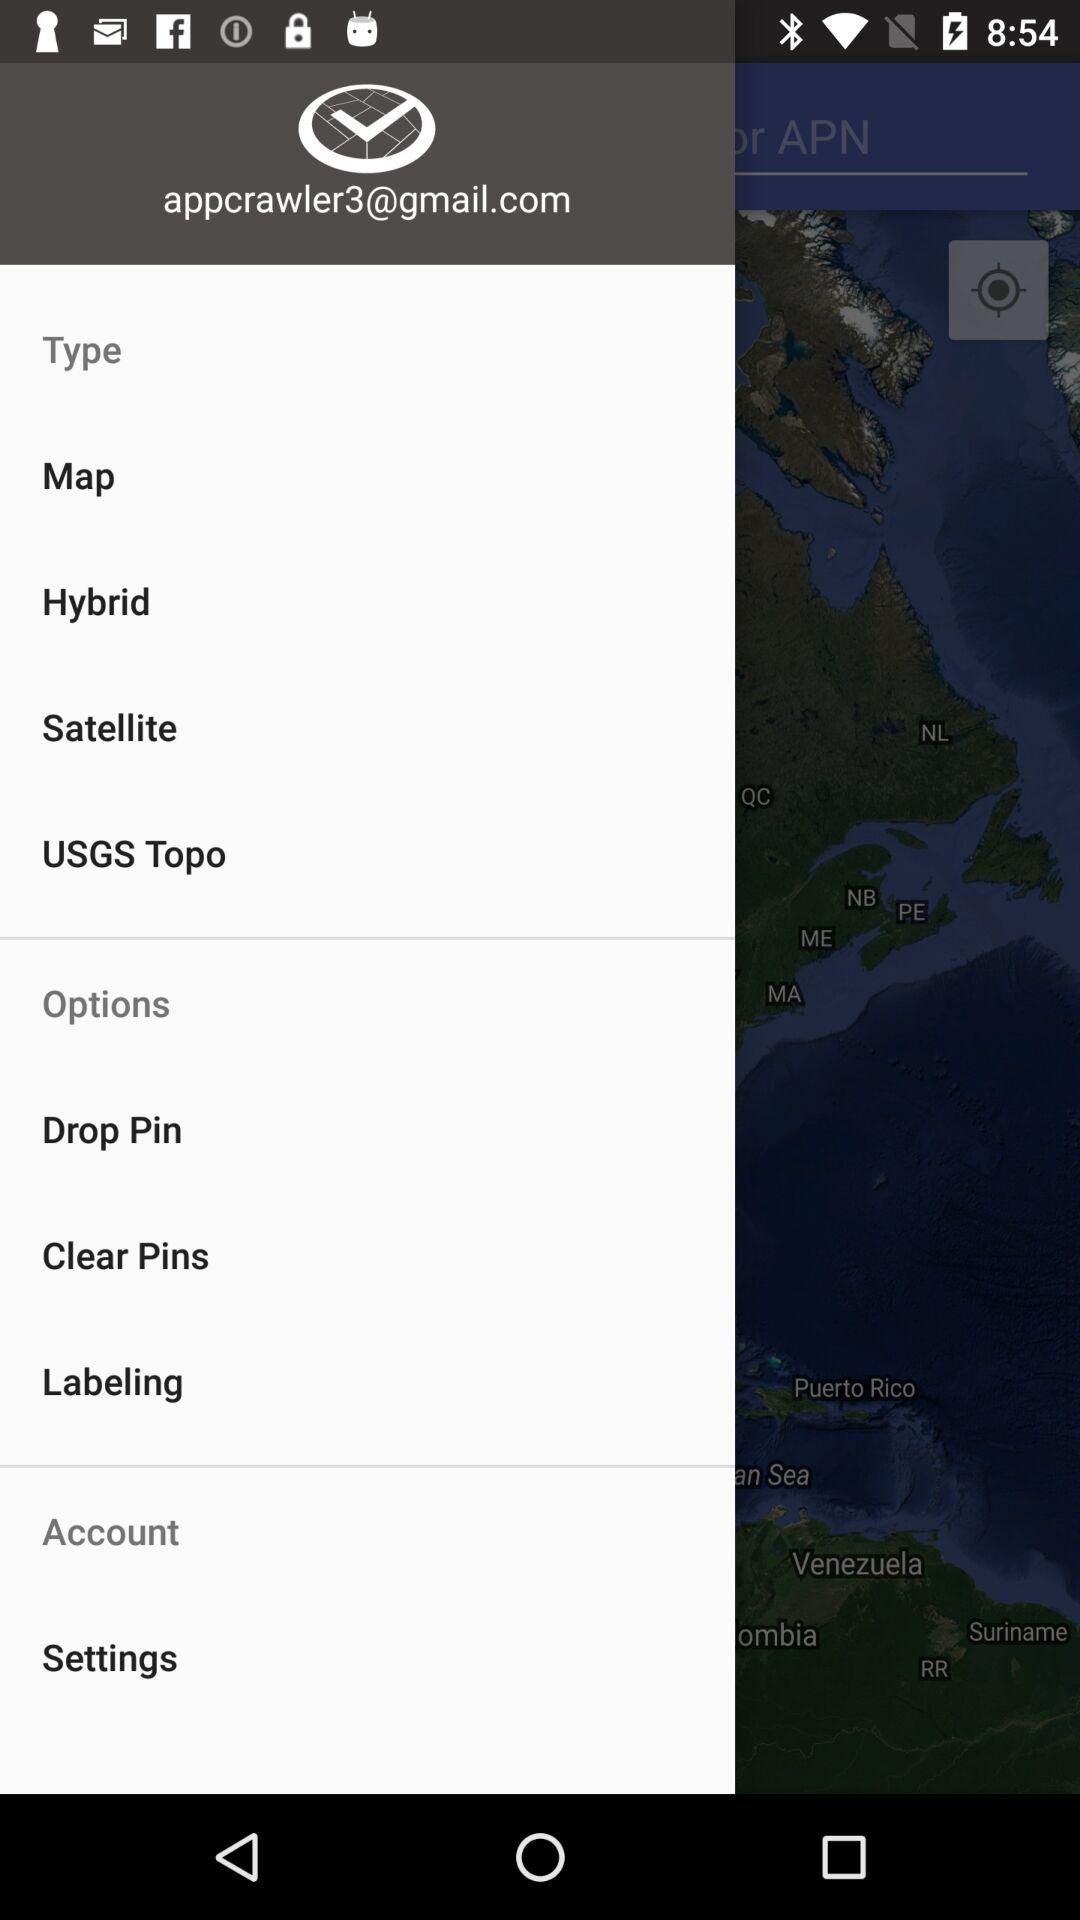What is the email address? The email address is appcrawler3@gmail.com. 